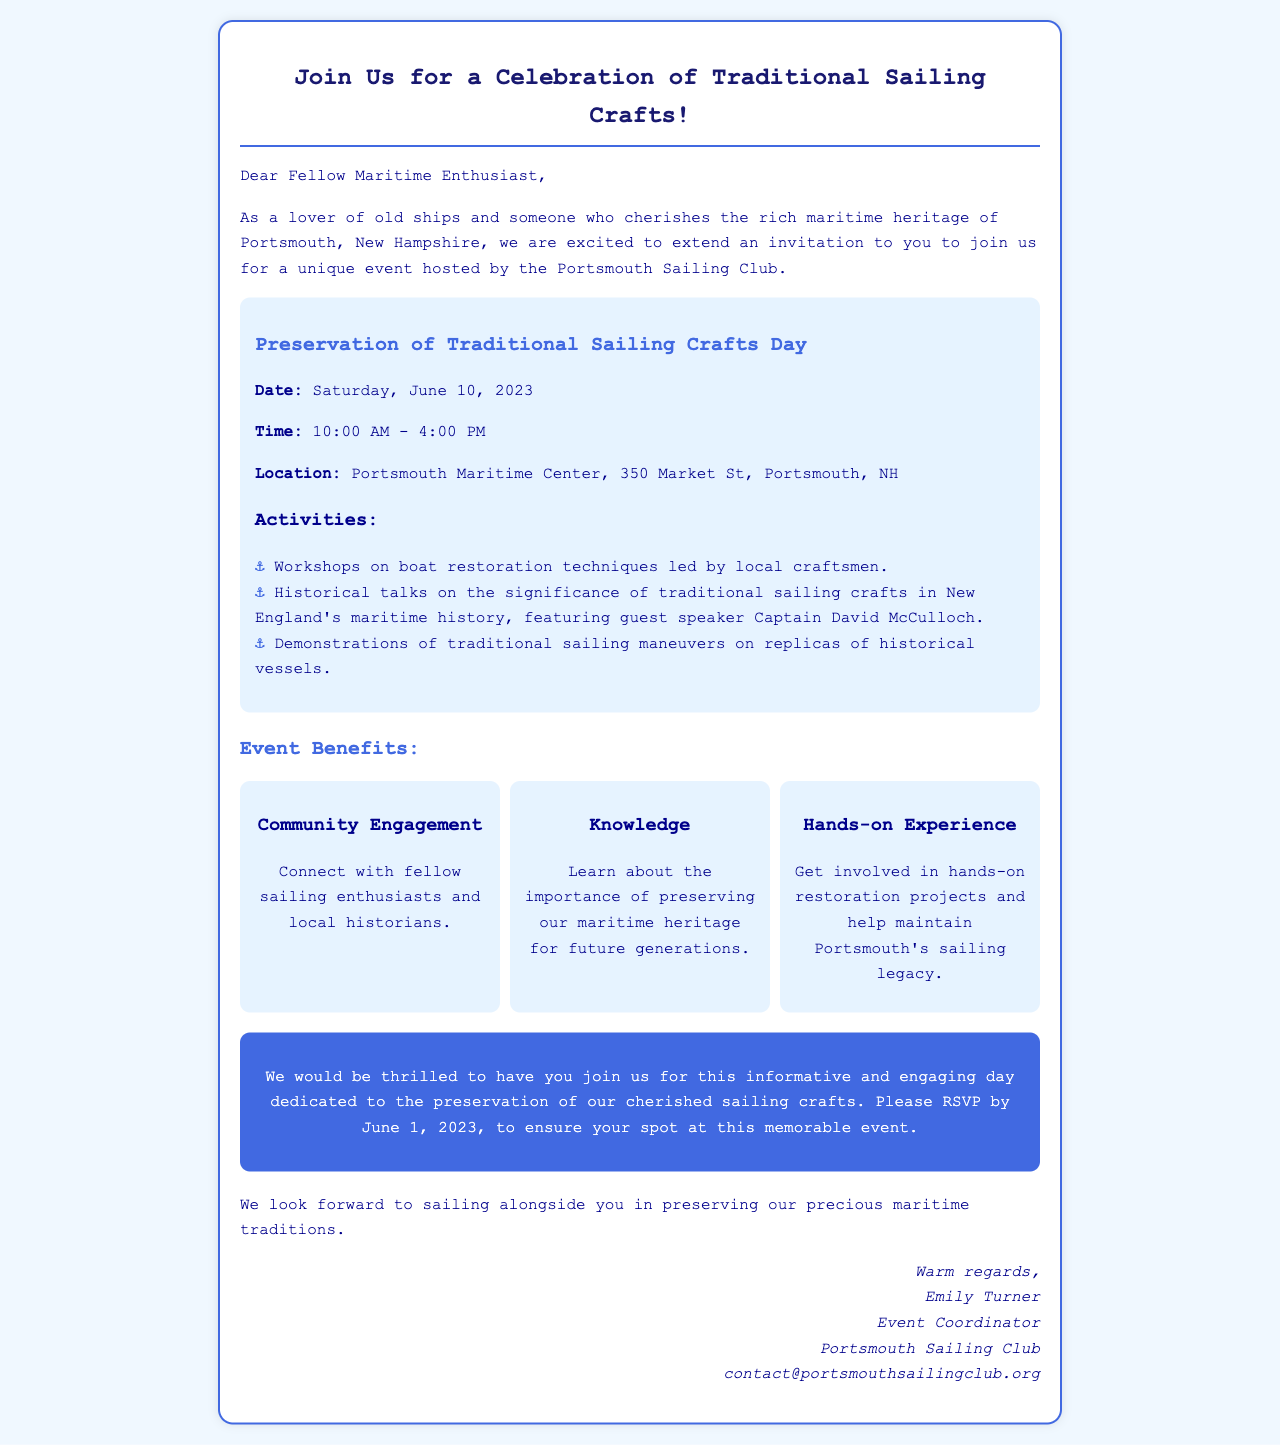What is the event being celebrated? The document mentions a specific event focusing on sailing crafts, which is dedicated to their preservation.
Answer: Preservation of Traditional Sailing Crafts Day What is the date of the event? The document explicitly states the date when the event will take place.
Answer: Saturday, June 10, 2023 What time does the event start? The starting time for the event is provided in the document.
Answer: 10:00 AM Where is the event located? The document provides the name and address of the venue for the event.
Answer: Portsmouth Maritime Center, 350 Market St, Portsmouth, NH Who is the guest speaker at the event? The document lists the name of the guest speaker who will be featured during the historical talks.
Answer: Captain David McCulloch What type of hands-on activity is mentioned in the document? The document lists hands-on experiences that participants can engage in during the event.
Answer: Restoration projects What is the RSVP deadline for the event? The RSVP deadline is specified in the document, necessary for potential attendees to ensure their participation.
Answer: June 1, 2023 What is one benefit of attending the event? The document outlines various benefits associated with the event, aimed at encouraging participation.
Answer: Community Engagement Who is organizing the event? The document includes the name of the event coordinator and the organization responsible for the event.
Answer: Portsmouth Sailing Club 